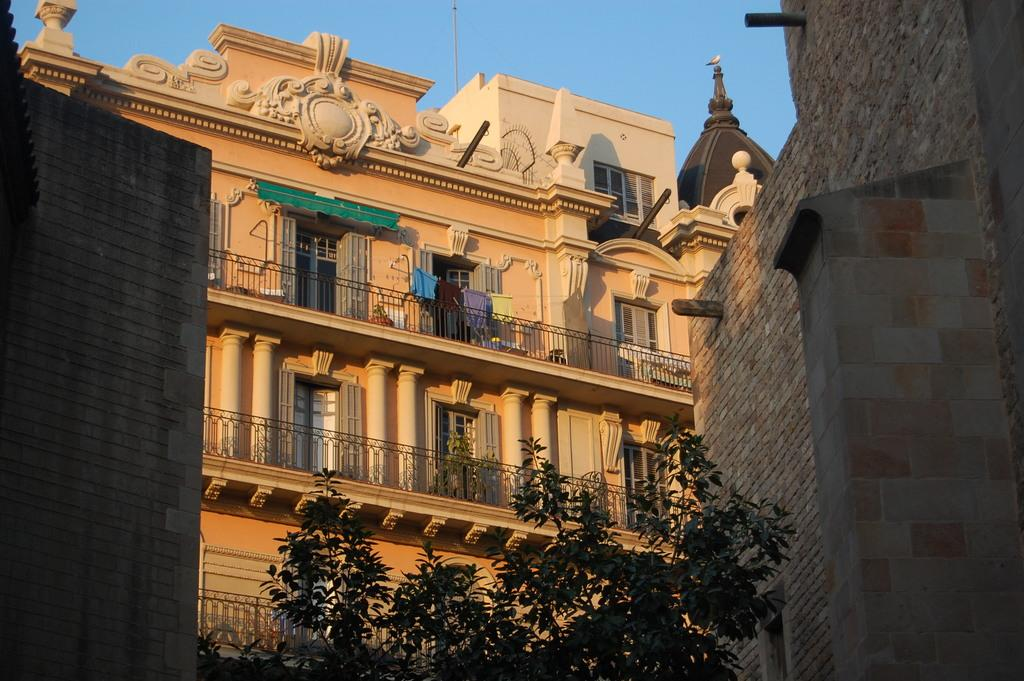What type of structure can be seen in the background of the image? There is a building in the background of the image. What is located in front of the building? There are trees in front of the building. What part of the natural environment is visible in the image? The sky is visible above the building. What type of boot is being worn by the visitor in the image? There is no visitor or boot present in the image. What type of skin condition can be seen on the trees in the image? There is no mention of any skin condition on the trees in the image; they appear to be healthy. 